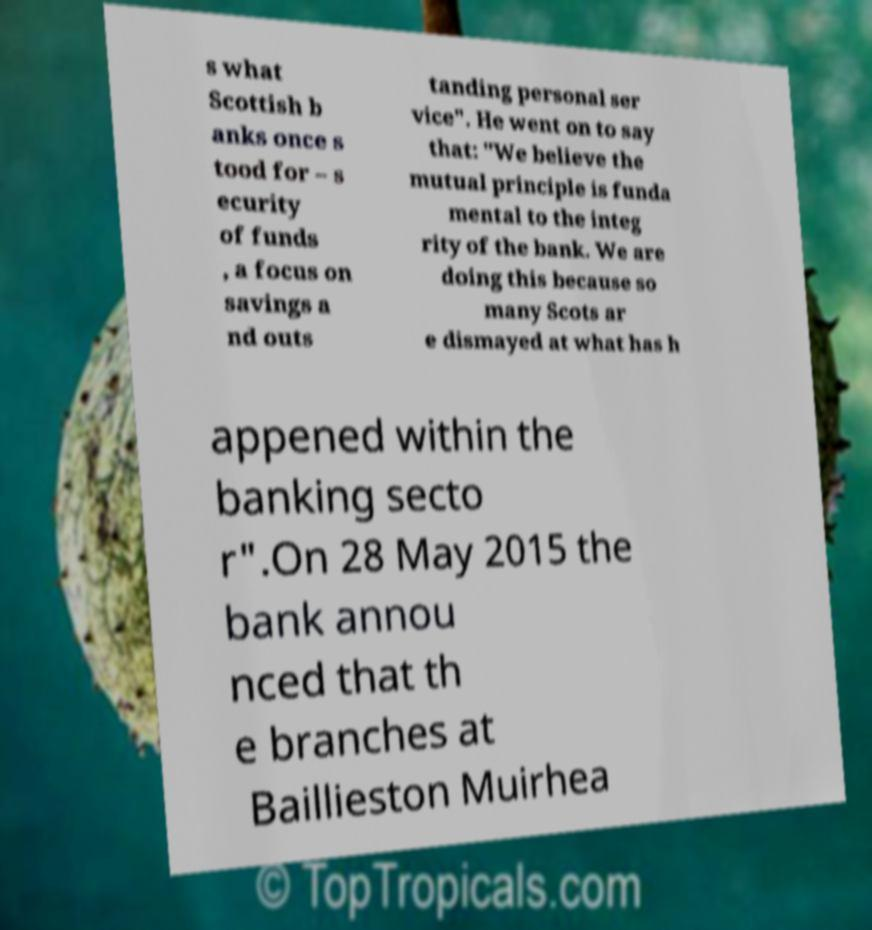Could you assist in decoding the text presented in this image and type it out clearly? s what Scottish b anks once s tood for – s ecurity of funds , a focus on savings a nd outs tanding personal ser vice". He went on to say that: "We believe the mutual principle is funda mental to the integ rity of the bank. We are doing this because so many Scots ar e dismayed at what has h appened within the banking secto r".On 28 May 2015 the bank annou nced that th e branches at Baillieston Muirhea 